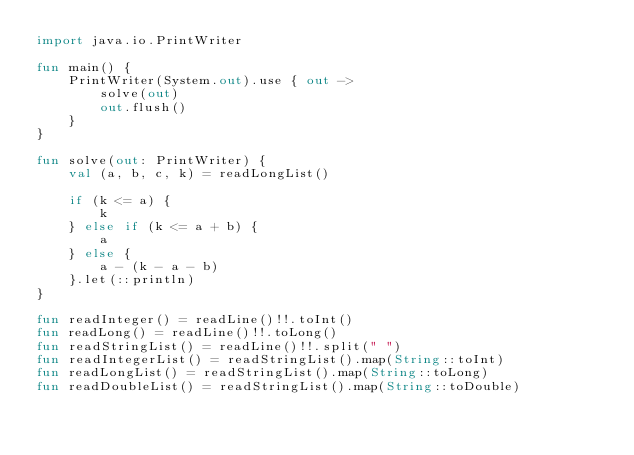<code> <loc_0><loc_0><loc_500><loc_500><_Kotlin_>import java.io.PrintWriter

fun main() {
    PrintWriter(System.out).use { out ->
        solve(out)
        out.flush()
    }
}

fun solve(out: PrintWriter) {
    val (a, b, c, k) = readLongList()

    if (k <= a) {
        k
    } else if (k <= a + b) {
        a
    } else {
        a - (k - a - b)
    }.let(::println)
}

fun readInteger() = readLine()!!.toInt()
fun readLong() = readLine()!!.toLong()
fun readStringList() = readLine()!!.split(" ")
fun readIntegerList() = readStringList().map(String::toInt)
fun readLongList() = readStringList().map(String::toLong)
fun readDoubleList() = readStringList().map(String::toDouble)
</code> 